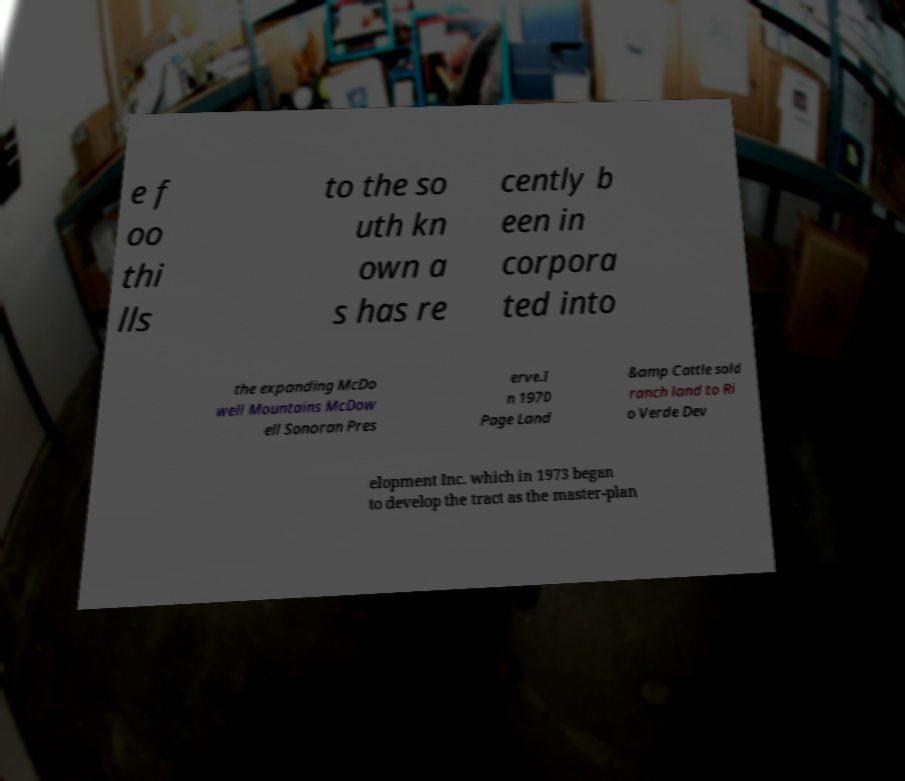What messages or text are displayed in this image? I need them in a readable, typed format. e f oo thi lls to the so uth kn own a s has re cently b een in corpora ted into the expanding McDo well Mountains McDow ell Sonoran Pres erve.I n 1970 Page Land &amp Cattle sold ranch land to Ri o Verde Dev elopment Inc. which in 1973 began to develop the tract as the master-plan 